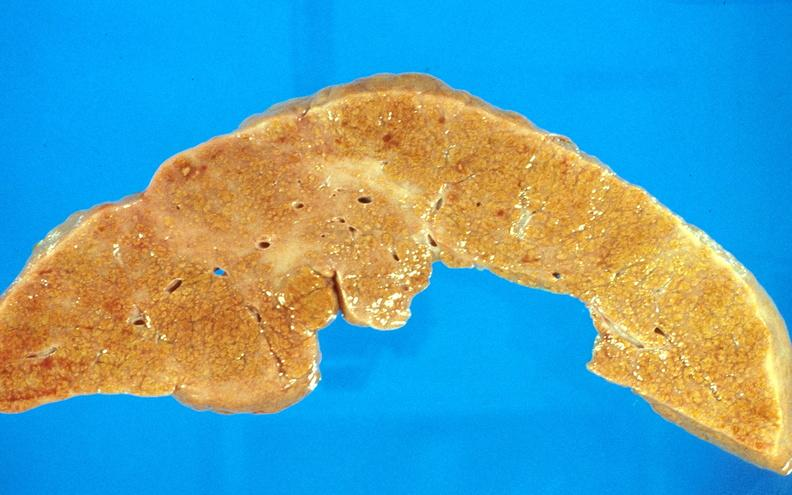s choanal patency present?
Answer the question using a single word or phrase. No 